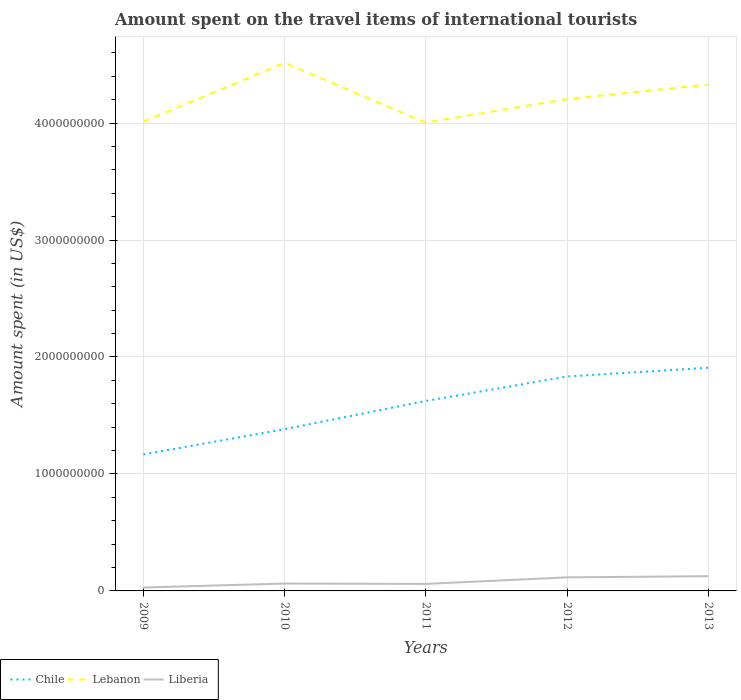Does the line corresponding to Liberia intersect with the line corresponding to Lebanon?
Provide a succinct answer. No. Is the number of lines equal to the number of legend labels?
Offer a very short reply. Yes. Across all years, what is the maximum amount spent on the travel items of international tourists in Liberia?
Provide a succinct answer. 2.90e+07. In which year was the amount spent on the travel items of international tourists in Lebanon maximum?
Your answer should be very brief. 2011. What is the total amount spent on the travel items of international tourists in Chile in the graph?
Give a very brief answer. -6.66e+08. What is the difference between the highest and the second highest amount spent on the travel items of international tourists in Chile?
Ensure brevity in your answer.  7.41e+08. What is the difference between the highest and the lowest amount spent on the travel items of international tourists in Chile?
Your answer should be compact. 3. Is the amount spent on the travel items of international tourists in Chile strictly greater than the amount spent on the travel items of international tourists in Lebanon over the years?
Your response must be concise. Yes. Are the values on the major ticks of Y-axis written in scientific E-notation?
Your answer should be compact. No. Does the graph contain any zero values?
Keep it short and to the point. No. Where does the legend appear in the graph?
Offer a very short reply. Bottom left. How are the legend labels stacked?
Provide a short and direct response. Horizontal. What is the title of the graph?
Ensure brevity in your answer.  Amount spent on the travel items of international tourists. What is the label or title of the Y-axis?
Ensure brevity in your answer.  Amount spent (in US$). What is the Amount spent (in US$) of Chile in 2009?
Make the answer very short. 1.17e+09. What is the Amount spent (in US$) in Lebanon in 2009?
Offer a very short reply. 4.01e+09. What is the Amount spent (in US$) in Liberia in 2009?
Offer a terse response. 2.90e+07. What is the Amount spent (in US$) of Chile in 2010?
Your answer should be very brief. 1.38e+09. What is the Amount spent (in US$) in Lebanon in 2010?
Your response must be concise. 4.52e+09. What is the Amount spent (in US$) of Liberia in 2010?
Keep it short and to the point. 6.30e+07. What is the Amount spent (in US$) of Chile in 2011?
Provide a short and direct response. 1.62e+09. What is the Amount spent (in US$) of Lebanon in 2011?
Ensure brevity in your answer.  4.00e+09. What is the Amount spent (in US$) in Liberia in 2011?
Your answer should be very brief. 6.00e+07. What is the Amount spent (in US$) in Chile in 2012?
Keep it short and to the point. 1.83e+09. What is the Amount spent (in US$) in Lebanon in 2012?
Your answer should be very brief. 4.20e+09. What is the Amount spent (in US$) in Liberia in 2012?
Offer a very short reply. 1.16e+08. What is the Amount spent (in US$) in Chile in 2013?
Offer a terse response. 1.91e+09. What is the Amount spent (in US$) of Lebanon in 2013?
Provide a short and direct response. 4.33e+09. What is the Amount spent (in US$) in Liberia in 2013?
Offer a very short reply. 1.26e+08. Across all years, what is the maximum Amount spent (in US$) of Chile?
Make the answer very short. 1.91e+09. Across all years, what is the maximum Amount spent (in US$) of Lebanon?
Keep it short and to the point. 4.52e+09. Across all years, what is the maximum Amount spent (in US$) in Liberia?
Keep it short and to the point. 1.26e+08. Across all years, what is the minimum Amount spent (in US$) of Chile?
Keep it short and to the point. 1.17e+09. Across all years, what is the minimum Amount spent (in US$) of Lebanon?
Offer a terse response. 4.00e+09. Across all years, what is the minimum Amount spent (in US$) in Liberia?
Your answer should be compact. 2.90e+07. What is the total Amount spent (in US$) in Chile in the graph?
Offer a terse response. 7.92e+09. What is the total Amount spent (in US$) of Lebanon in the graph?
Ensure brevity in your answer.  2.11e+1. What is the total Amount spent (in US$) in Liberia in the graph?
Provide a short and direct response. 3.94e+08. What is the difference between the Amount spent (in US$) in Chile in 2009 and that in 2010?
Give a very brief answer. -2.16e+08. What is the difference between the Amount spent (in US$) in Lebanon in 2009 and that in 2010?
Your response must be concise. -5.03e+08. What is the difference between the Amount spent (in US$) of Liberia in 2009 and that in 2010?
Make the answer very short. -3.40e+07. What is the difference between the Amount spent (in US$) in Chile in 2009 and that in 2011?
Offer a very short reply. -4.57e+08. What is the difference between the Amount spent (in US$) in Liberia in 2009 and that in 2011?
Provide a succinct answer. -3.10e+07. What is the difference between the Amount spent (in US$) in Chile in 2009 and that in 2012?
Your answer should be very brief. -6.66e+08. What is the difference between the Amount spent (in US$) in Lebanon in 2009 and that in 2012?
Your answer should be compact. -1.93e+08. What is the difference between the Amount spent (in US$) in Liberia in 2009 and that in 2012?
Provide a succinct answer. -8.70e+07. What is the difference between the Amount spent (in US$) in Chile in 2009 and that in 2013?
Keep it short and to the point. -7.41e+08. What is the difference between the Amount spent (in US$) in Lebanon in 2009 and that in 2013?
Offer a very short reply. -3.17e+08. What is the difference between the Amount spent (in US$) in Liberia in 2009 and that in 2013?
Make the answer very short. -9.70e+07. What is the difference between the Amount spent (in US$) of Chile in 2010 and that in 2011?
Your answer should be very brief. -2.41e+08. What is the difference between the Amount spent (in US$) of Lebanon in 2010 and that in 2011?
Your answer should be very brief. 5.11e+08. What is the difference between the Amount spent (in US$) in Chile in 2010 and that in 2012?
Offer a very short reply. -4.50e+08. What is the difference between the Amount spent (in US$) in Lebanon in 2010 and that in 2012?
Your response must be concise. 3.10e+08. What is the difference between the Amount spent (in US$) of Liberia in 2010 and that in 2012?
Offer a very short reply. -5.30e+07. What is the difference between the Amount spent (in US$) in Chile in 2010 and that in 2013?
Your answer should be very brief. -5.25e+08. What is the difference between the Amount spent (in US$) of Lebanon in 2010 and that in 2013?
Give a very brief answer. 1.86e+08. What is the difference between the Amount spent (in US$) in Liberia in 2010 and that in 2013?
Your answer should be very brief. -6.30e+07. What is the difference between the Amount spent (in US$) of Chile in 2011 and that in 2012?
Offer a terse response. -2.09e+08. What is the difference between the Amount spent (in US$) of Lebanon in 2011 and that in 2012?
Make the answer very short. -2.01e+08. What is the difference between the Amount spent (in US$) in Liberia in 2011 and that in 2012?
Your response must be concise. -5.60e+07. What is the difference between the Amount spent (in US$) of Chile in 2011 and that in 2013?
Ensure brevity in your answer.  -2.84e+08. What is the difference between the Amount spent (in US$) of Lebanon in 2011 and that in 2013?
Provide a succinct answer. -3.25e+08. What is the difference between the Amount spent (in US$) of Liberia in 2011 and that in 2013?
Provide a succinct answer. -6.60e+07. What is the difference between the Amount spent (in US$) of Chile in 2012 and that in 2013?
Your answer should be compact. -7.50e+07. What is the difference between the Amount spent (in US$) in Lebanon in 2012 and that in 2013?
Keep it short and to the point. -1.24e+08. What is the difference between the Amount spent (in US$) of Liberia in 2012 and that in 2013?
Provide a succinct answer. -1.00e+07. What is the difference between the Amount spent (in US$) in Chile in 2009 and the Amount spent (in US$) in Lebanon in 2010?
Ensure brevity in your answer.  -3.35e+09. What is the difference between the Amount spent (in US$) in Chile in 2009 and the Amount spent (in US$) in Liberia in 2010?
Ensure brevity in your answer.  1.10e+09. What is the difference between the Amount spent (in US$) of Lebanon in 2009 and the Amount spent (in US$) of Liberia in 2010?
Ensure brevity in your answer.  3.95e+09. What is the difference between the Amount spent (in US$) in Chile in 2009 and the Amount spent (in US$) in Lebanon in 2011?
Make the answer very short. -2.84e+09. What is the difference between the Amount spent (in US$) in Chile in 2009 and the Amount spent (in US$) in Liberia in 2011?
Give a very brief answer. 1.11e+09. What is the difference between the Amount spent (in US$) in Lebanon in 2009 and the Amount spent (in US$) in Liberia in 2011?
Provide a short and direct response. 3.95e+09. What is the difference between the Amount spent (in US$) in Chile in 2009 and the Amount spent (in US$) in Lebanon in 2012?
Your response must be concise. -3.04e+09. What is the difference between the Amount spent (in US$) of Chile in 2009 and the Amount spent (in US$) of Liberia in 2012?
Your response must be concise. 1.05e+09. What is the difference between the Amount spent (in US$) of Lebanon in 2009 and the Amount spent (in US$) of Liberia in 2012?
Your answer should be compact. 3.90e+09. What is the difference between the Amount spent (in US$) of Chile in 2009 and the Amount spent (in US$) of Lebanon in 2013?
Offer a very short reply. -3.16e+09. What is the difference between the Amount spent (in US$) in Chile in 2009 and the Amount spent (in US$) in Liberia in 2013?
Offer a terse response. 1.04e+09. What is the difference between the Amount spent (in US$) of Lebanon in 2009 and the Amount spent (in US$) of Liberia in 2013?
Your answer should be compact. 3.89e+09. What is the difference between the Amount spent (in US$) in Chile in 2010 and the Amount spent (in US$) in Lebanon in 2011?
Provide a short and direct response. -2.62e+09. What is the difference between the Amount spent (in US$) in Chile in 2010 and the Amount spent (in US$) in Liberia in 2011?
Your answer should be compact. 1.32e+09. What is the difference between the Amount spent (in US$) in Lebanon in 2010 and the Amount spent (in US$) in Liberia in 2011?
Offer a terse response. 4.46e+09. What is the difference between the Amount spent (in US$) of Chile in 2010 and the Amount spent (in US$) of Lebanon in 2012?
Your response must be concise. -2.82e+09. What is the difference between the Amount spent (in US$) in Chile in 2010 and the Amount spent (in US$) in Liberia in 2012?
Your answer should be very brief. 1.27e+09. What is the difference between the Amount spent (in US$) in Lebanon in 2010 and the Amount spent (in US$) in Liberia in 2012?
Ensure brevity in your answer.  4.40e+09. What is the difference between the Amount spent (in US$) of Chile in 2010 and the Amount spent (in US$) of Lebanon in 2013?
Your answer should be compact. -2.95e+09. What is the difference between the Amount spent (in US$) in Chile in 2010 and the Amount spent (in US$) in Liberia in 2013?
Keep it short and to the point. 1.26e+09. What is the difference between the Amount spent (in US$) in Lebanon in 2010 and the Amount spent (in US$) in Liberia in 2013?
Your answer should be very brief. 4.39e+09. What is the difference between the Amount spent (in US$) in Chile in 2011 and the Amount spent (in US$) in Lebanon in 2012?
Provide a short and direct response. -2.58e+09. What is the difference between the Amount spent (in US$) in Chile in 2011 and the Amount spent (in US$) in Liberia in 2012?
Keep it short and to the point. 1.51e+09. What is the difference between the Amount spent (in US$) of Lebanon in 2011 and the Amount spent (in US$) of Liberia in 2012?
Offer a terse response. 3.89e+09. What is the difference between the Amount spent (in US$) in Chile in 2011 and the Amount spent (in US$) in Lebanon in 2013?
Offer a terse response. -2.70e+09. What is the difference between the Amount spent (in US$) in Chile in 2011 and the Amount spent (in US$) in Liberia in 2013?
Make the answer very short. 1.50e+09. What is the difference between the Amount spent (in US$) in Lebanon in 2011 and the Amount spent (in US$) in Liberia in 2013?
Give a very brief answer. 3.88e+09. What is the difference between the Amount spent (in US$) in Chile in 2012 and the Amount spent (in US$) in Lebanon in 2013?
Keep it short and to the point. -2.50e+09. What is the difference between the Amount spent (in US$) in Chile in 2012 and the Amount spent (in US$) in Liberia in 2013?
Keep it short and to the point. 1.71e+09. What is the difference between the Amount spent (in US$) in Lebanon in 2012 and the Amount spent (in US$) in Liberia in 2013?
Offer a terse response. 4.08e+09. What is the average Amount spent (in US$) of Chile per year?
Provide a succinct answer. 1.58e+09. What is the average Amount spent (in US$) in Lebanon per year?
Provide a short and direct response. 4.21e+09. What is the average Amount spent (in US$) of Liberia per year?
Offer a terse response. 7.88e+07. In the year 2009, what is the difference between the Amount spent (in US$) in Chile and Amount spent (in US$) in Lebanon?
Your answer should be compact. -2.84e+09. In the year 2009, what is the difference between the Amount spent (in US$) of Chile and Amount spent (in US$) of Liberia?
Make the answer very short. 1.14e+09. In the year 2009, what is the difference between the Amount spent (in US$) of Lebanon and Amount spent (in US$) of Liberia?
Provide a succinct answer. 3.98e+09. In the year 2010, what is the difference between the Amount spent (in US$) of Chile and Amount spent (in US$) of Lebanon?
Make the answer very short. -3.13e+09. In the year 2010, what is the difference between the Amount spent (in US$) of Chile and Amount spent (in US$) of Liberia?
Give a very brief answer. 1.32e+09. In the year 2010, what is the difference between the Amount spent (in US$) of Lebanon and Amount spent (in US$) of Liberia?
Offer a very short reply. 4.45e+09. In the year 2011, what is the difference between the Amount spent (in US$) of Chile and Amount spent (in US$) of Lebanon?
Provide a succinct answer. -2.38e+09. In the year 2011, what is the difference between the Amount spent (in US$) of Chile and Amount spent (in US$) of Liberia?
Make the answer very short. 1.56e+09. In the year 2011, what is the difference between the Amount spent (in US$) in Lebanon and Amount spent (in US$) in Liberia?
Your answer should be very brief. 3.94e+09. In the year 2012, what is the difference between the Amount spent (in US$) of Chile and Amount spent (in US$) of Lebanon?
Make the answer very short. -2.37e+09. In the year 2012, what is the difference between the Amount spent (in US$) of Chile and Amount spent (in US$) of Liberia?
Give a very brief answer. 1.72e+09. In the year 2012, what is the difference between the Amount spent (in US$) in Lebanon and Amount spent (in US$) in Liberia?
Your answer should be very brief. 4.09e+09. In the year 2013, what is the difference between the Amount spent (in US$) in Chile and Amount spent (in US$) in Lebanon?
Your answer should be very brief. -2.42e+09. In the year 2013, what is the difference between the Amount spent (in US$) of Chile and Amount spent (in US$) of Liberia?
Offer a terse response. 1.78e+09. In the year 2013, what is the difference between the Amount spent (in US$) of Lebanon and Amount spent (in US$) of Liberia?
Offer a terse response. 4.20e+09. What is the ratio of the Amount spent (in US$) in Chile in 2009 to that in 2010?
Your response must be concise. 0.84. What is the ratio of the Amount spent (in US$) in Lebanon in 2009 to that in 2010?
Your answer should be compact. 0.89. What is the ratio of the Amount spent (in US$) in Liberia in 2009 to that in 2010?
Your answer should be compact. 0.46. What is the ratio of the Amount spent (in US$) of Chile in 2009 to that in 2011?
Your answer should be compact. 0.72. What is the ratio of the Amount spent (in US$) in Liberia in 2009 to that in 2011?
Your response must be concise. 0.48. What is the ratio of the Amount spent (in US$) in Chile in 2009 to that in 2012?
Offer a terse response. 0.64. What is the ratio of the Amount spent (in US$) in Lebanon in 2009 to that in 2012?
Your answer should be very brief. 0.95. What is the ratio of the Amount spent (in US$) in Chile in 2009 to that in 2013?
Provide a succinct answer. 0.61. What is the ratio of the Amount spent (in US$) in Lebanon in 2009 to that in 2013?
Offer a terse response. 0.93. What is the ratio of the Amount spent (in US$) in Liberia in 2009 to that in 2013?
Your response must be concise. 0.23. What is the ratio of the Amount spent (in US$) of Chile in 2010 to that in 2011?
Keep it short and to the point. 0.85. What is the ratio of the Amount spent (in US$) in Lebanon in 2010 to that in 2011?
Your response must be concise. 1.13. What is the ratio of the Amount spent (in US$) in Chile in 2010 to that in 2012?
Your answer should be compact. 0.75. What is the ratio of the Amount spent (in US$) in Lebanon in 2010 to that in 2012?
Offer a terse response. 1.07. What is the ratio of the Amount spent (in US$) of Liberia in 2010 to that in 2012?
Your answer should be very brief. 0.54. What is the ratio of the Amount spent (in US$) in Chile in 2010 to that in 2013?
Offer a terse response. 0.72. What is the ratio of the Amount spent (in US$) in Lebanon in 2010 to that in 2013?
Keep it short and to the point. 1.04. What is the ratio of the Amount spent (in US$) in Chile in 2011 to that in 2012?
Give a very brief answer. 0.89. What is the ratio of the Amount spent (in US$) of Lebanon in 2011 to that in 2012?
Make the answer very short. 0.95. What is the ratio of the Amount spent (in US$) in Liberia in 2011 to that in 2012?
Your answer should be compact. 0.52. What is the ratio of the Amount spent (in US$) in Chile in 2011 to that in 2013?
Give a very brief answer. 0.85. What is the ratio of the Amount spent (in US$) in Lebanon in 2011 to that in 2013?
Offer a very short reply. 0.92. What is the ratio of the Amount spent (in US$) of Liberia in 2011 to that in 2013?
Ensure brevity in your answer.  0.48. What is the ratio of the Amount spent (in US$) in Chile in 2012 to that in 2013?
Provide a short and direct response. 0.96. What is the ratio of the Amount spent (in US$) in Lebanon in 2012 to that in 2013?
Give a very brief answer. 0.97. What is the ratio of the Amount spent (in US$) in Liberia in 2012 to that in 2013?
Make the answer very short. 0.92. What is the difference between the highest and the second highest Amount spent (in US$) of Chile?
Your answer should be compact. 7.50e+07. What is the difference between the highest and the second highest Amount spent (in US$) in Lebanon?
Give a very brief answer. 1.86e+08. What is the difference between the highest and the lowest Amount spent (in US$) in Chile?
Provide a succinct answer. 7.41e+08. What is the difference between the highest and the lowest Amount spent (in US$) of Lebanon?
Offer a terse response. 5.11e+08. What is the difference between the highest and the lowest Amount spent (in US$) of Liberia?
Provide a succinct answer. 9.70e+07. 